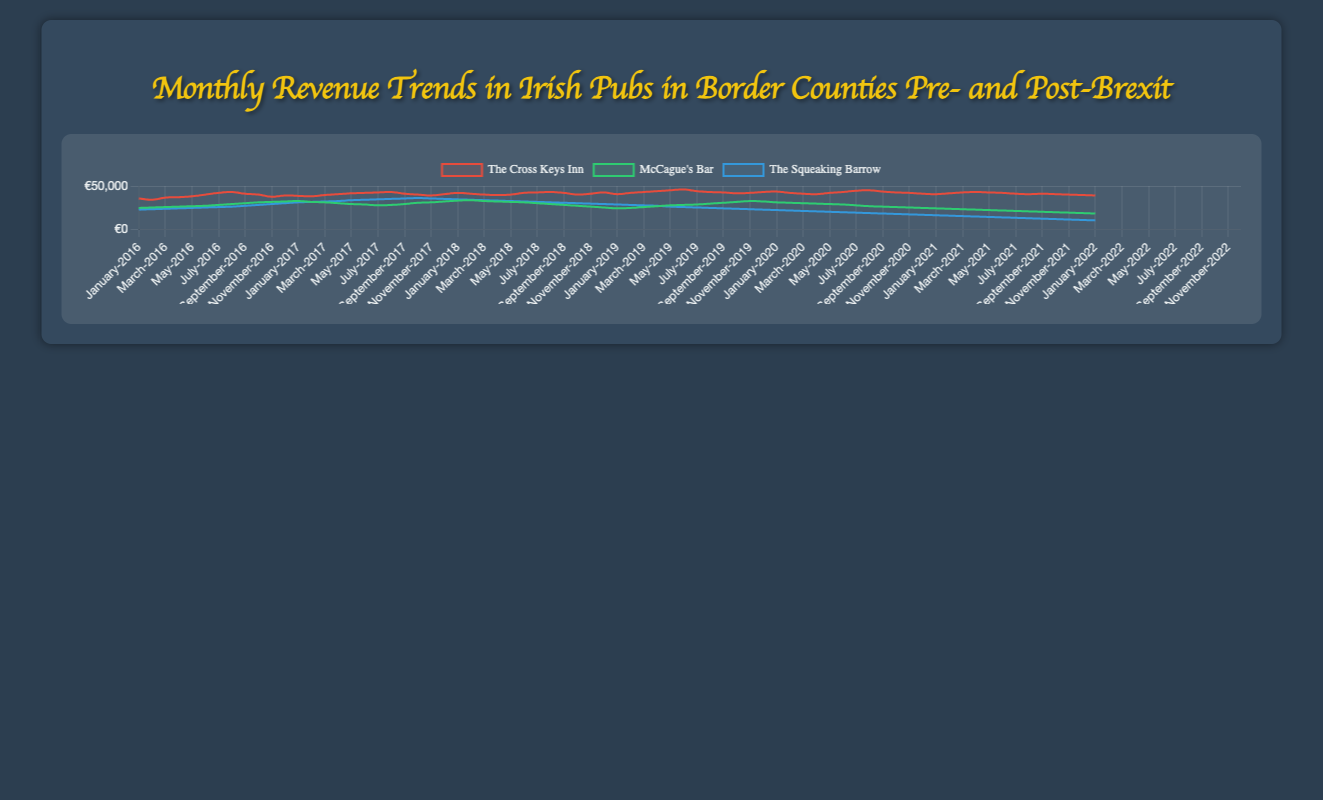What is the overall trend in monthly revenue for The Cross Keys Inn from January 2016 to December 2022? The line for The Cross Keys Inn shows an upward trend, starting at €35,500 in January 2016 and ending at €39,000 in December 2022. This indicates that the revenue has generally increased over time despite some fluctuations.
Answer: Increasing trend How did McCague's Bar's revenue change from December 2016 to March 2020? In December 2016, McCague's Bar's revenue was €32,000. By March 2020, it had decreased to €29,500, showing a slight downward trend during this period.
Answer: Decreasing trend Which pub experienced the most significant drop in revenue post-Brexit (i.e., after January 2020)? Comparing the lines for all three pubs from January 2020 onwards, The Squeaking Barrow shows the most significant drop in revenue, descending from around €21,000 in January 2020 to €10,000 in December 2022.
Answer: The Squeaking Barrow What is the average monthly revenue for McCague's Bar in 2017? Adding up the monthly revenues for McCague's Bar in 2017 (32500+31500+31000+30000+29000+28500+27500+28000+29000+30500+31000+32000) gives a total of 361000. Dividing this by 12 months results in an average of €30,083.33.
Answer: €30,083.33 Which pub had the highest revenue in December 2019? Observing the data points for December 2019, The Cross Keys Inn had the highest revenue at €42,500 compared to McCague's Bar (€32,000) and The Squeaking Barrow (€22,500).
Answer: The Cross Keys Inn How does the revenue of The Cross Keys Inn in January 2021 compare to its revenue in January 2018? In January 2021, The Cross Keys Inn had a revenue of €42,000, while in January 2018, it was €42,000. This indicates that the revenue remained the same during these points in time.
Answer: Equal Calculate the difference in revenue for The Squeaking Barrow between April 2020 and December 2022. The revenue for The Squeaking Barrow in April 2020 was €19,500 and in December 2022 was €10,000. The difference in revenue is €19,500 - €10,000 = €9,500.
Answer: €9,500 What is the trend in revenue for McCague's Bar between January 2019 and July 2019? McCague's Bar's revenue in January 2019 was €24,000, increasing to €28,500 in July 2019. This shows an upward trend during this period.
Answer: Increasing trend Which pub showed the steadiest revenue pattern throughout 2018? Comparing the lines for 2018, The Cross Keys Inn shows a relatively stable pattern, fluctuating between €40,000 and €42,500 while minimizing large variances compared to McCague's Bar and The Squeaking Barrow.
Answer: The Cross Keys Inn Which pub experienced the earliest significant decline in revenue post-Brexit? Analyzing the visual representation, McCague's Bar showed a notable decline starting around January 2019, earlier than the other pubs.
Answer: McCague's Bar 